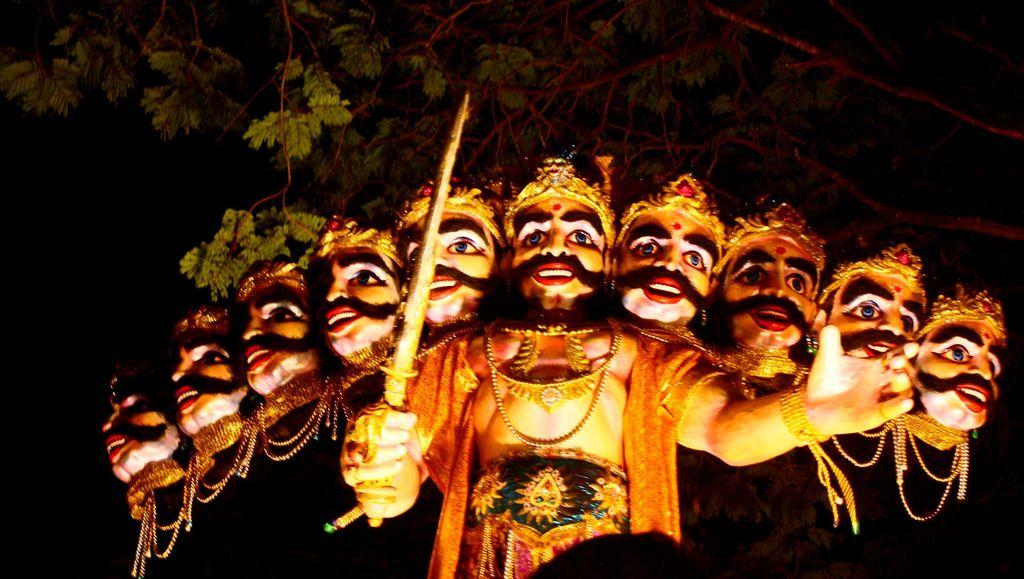What is the main subject of the picture? The main subject of the picture is an idol. What distinguishing feature does the idol have? The idol has many heads. What object is present in the picture alongside the idol? There is a sword in the picture. What can be seen in the background of the picture? There is a tree in the backdrop of the picture. How would you describe the overall lighting in the image? The rest of the image is dark. What type of statement is being made by the pear in the image? There is no pear present in the image, so no statement can be attributed to it. What color is the skirt of the idol in the image? The idol in the image does not have a skirt, so there is no color to describe. 